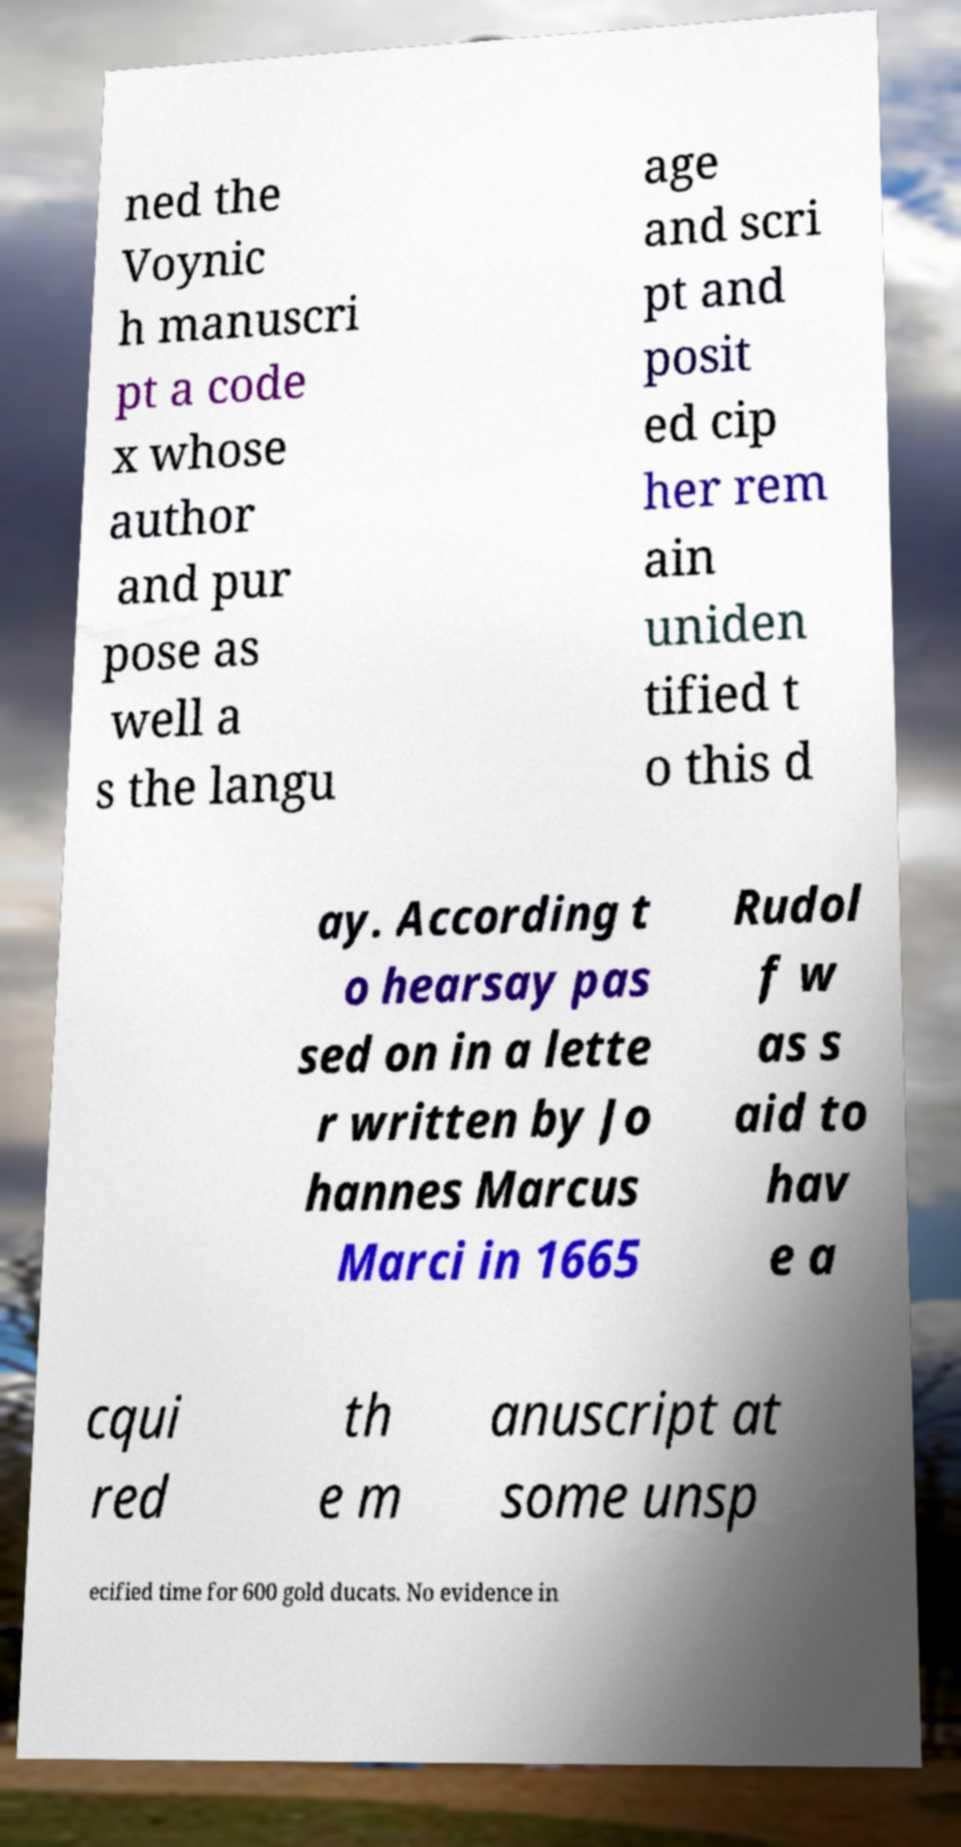Could you assist in decoding the text presented in this image and type it out clearly? ned the Voynic h manuscri pt a code x whose author and pur pose as well a s the langu age and scri pt and posit ed cip her rem ain uniden tified t o this d ay. According t o hearsay pas sed on in a lette r written by Jo hannes Marcus Marci in 1665 Rudol f w as s aid to hav e a cqui red th e m anuscript at some unsp ecified time for 600 gold ducats. No evidence in 